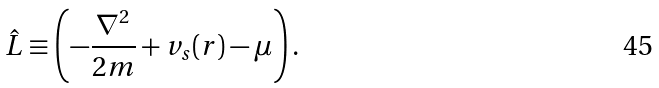Convert formula to latex. <formula><loc_0><loc_0><loc_500><loc_500>\hat { L } \equiv \left ( - \frac { \nabla ^ { 2 } } { 2 m } + v _ { s } ( { r } ) - \mu \right ) .</formula> 